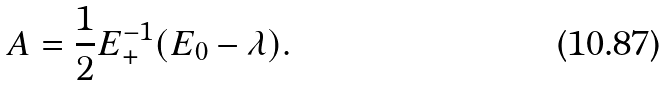Convert formula to latex. <formula><loc_0><loc_0><loc_500><loc_500>A = \frac { 1 } { 2 } E _ { + } ^ { - 1 } ( E _ { 0 } - \lambda ) .</formula> 